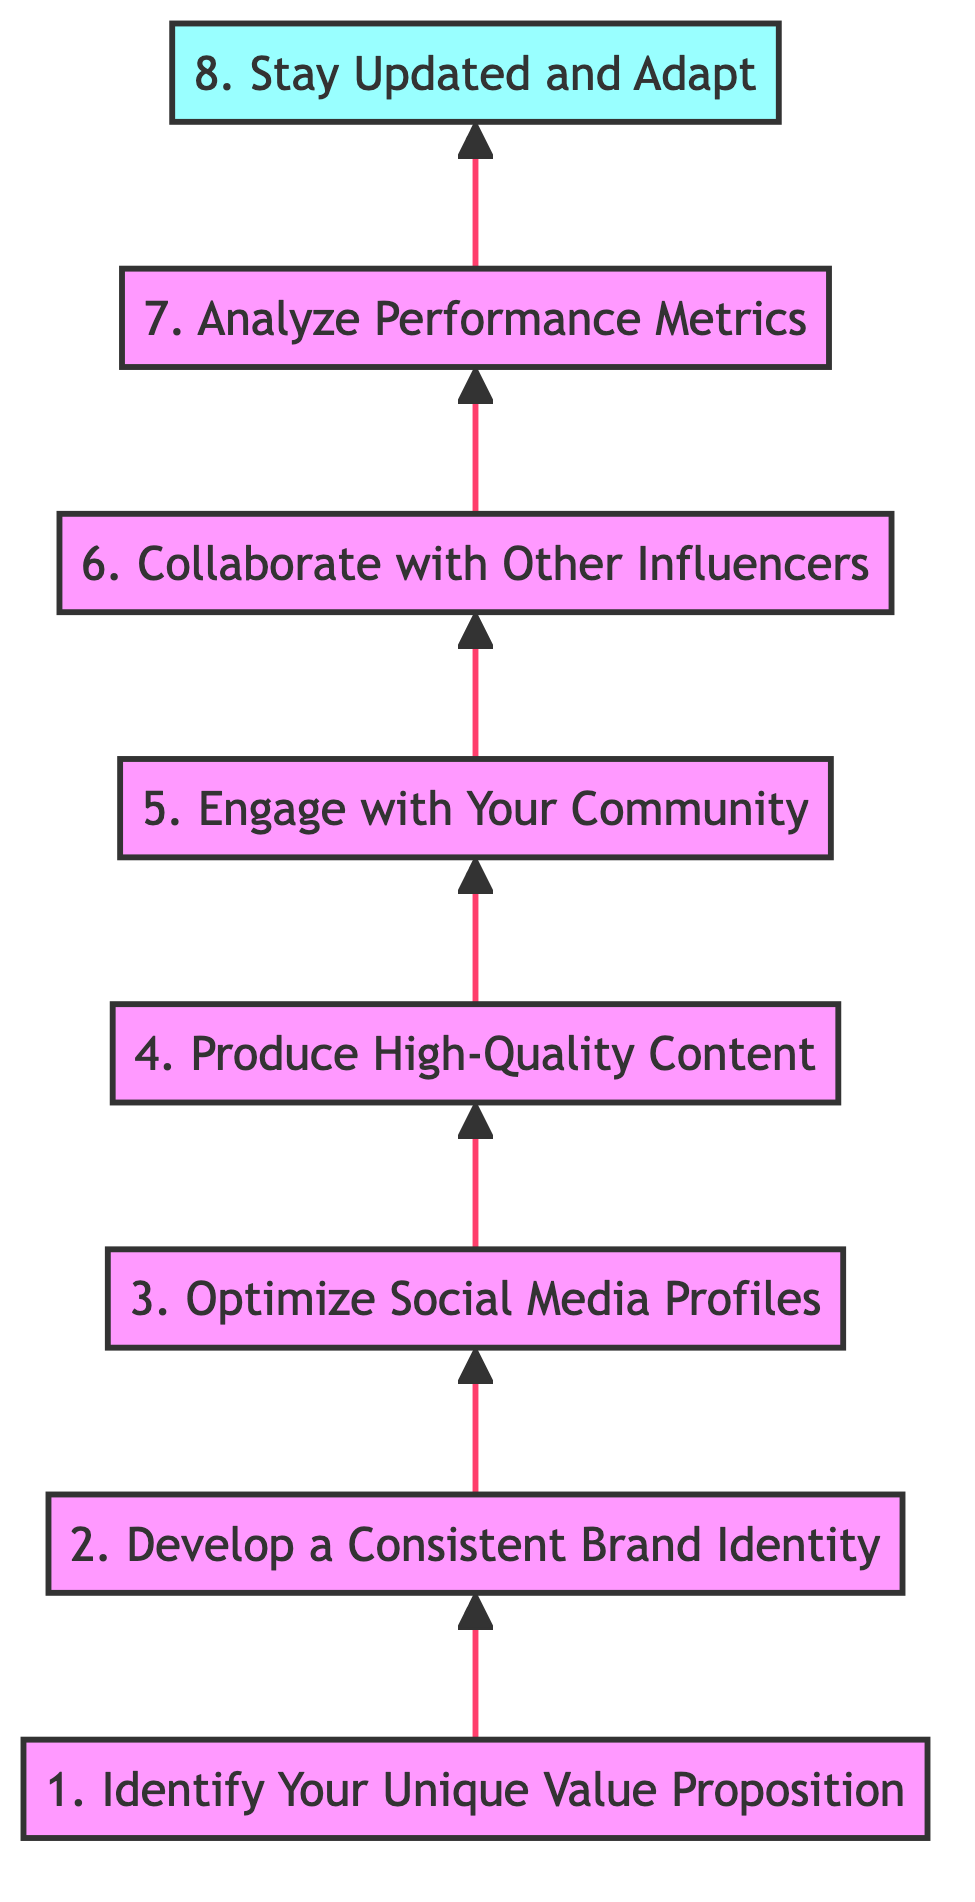What is the first step in building an engaging online brand? The first step, as indicated in the diagram, is "Identify Your Unique Value Proposition." This is the initial node in the flowchart, establishing the foundation for the entire branding process.
Answer: Identify Your Unique Value Proposition Which step comes before "Produce High-Quality Content"? In the flowchart, the step immediately before "Produce High-Quality Content" is "Optimize Social Media Profiles." This shows a direct flow from optimizing profiles to content production.
Answer: Optimize Social Media Profiles What is the last step in the flowchart? The last step, located at the top of the flowchart, is "Stay Updated and Adapt." Being at the end signifies its importance as the final action in the branding process.
Answer: Stay Updated and Adapt How many nodes are in the diagram? The diagram consists of eight nodes, each representing a unique step in the process of building an engaging online brand. This can be counted from the listed elements.
Answer: Eight What relationship exists between "Engage with Your Community" and "Collaborate with Other Influencers"? "Engage with Your Community" is directly followed by "Collaborate with Other Influencers," indicating a sequential relationship where engaging with the audience leads to collaborations.
Answer: Sequential relationship What is a key aspect of the second step? The second step, "Develop a Consistent Brand Identity," focuses on creating a cohesive look and feel across platforms by using consistent colors and design elements. This highlights the importance of visual identity in branding.
Answer: Cohesive look and feel What is the purpose of the "Analyze Performance Metrics" step? "Analyze Performance Metrics" serves to track engagement and growth on various platforms, utilizing analytics tools to inform and adjust strategies. This step is crucial for optimizing future actions based on data-driven insights.
Answer: Track engagement and growth Which steps focus on content creation? The steps that focus on content creation are "Produce High-Quality Content" and "Engage with Your Community." These steps emphasize both the quality of content produced and the importance of interacting with the community around that content.
Answer: Produce High-Quality Content and Engage with Your Community 